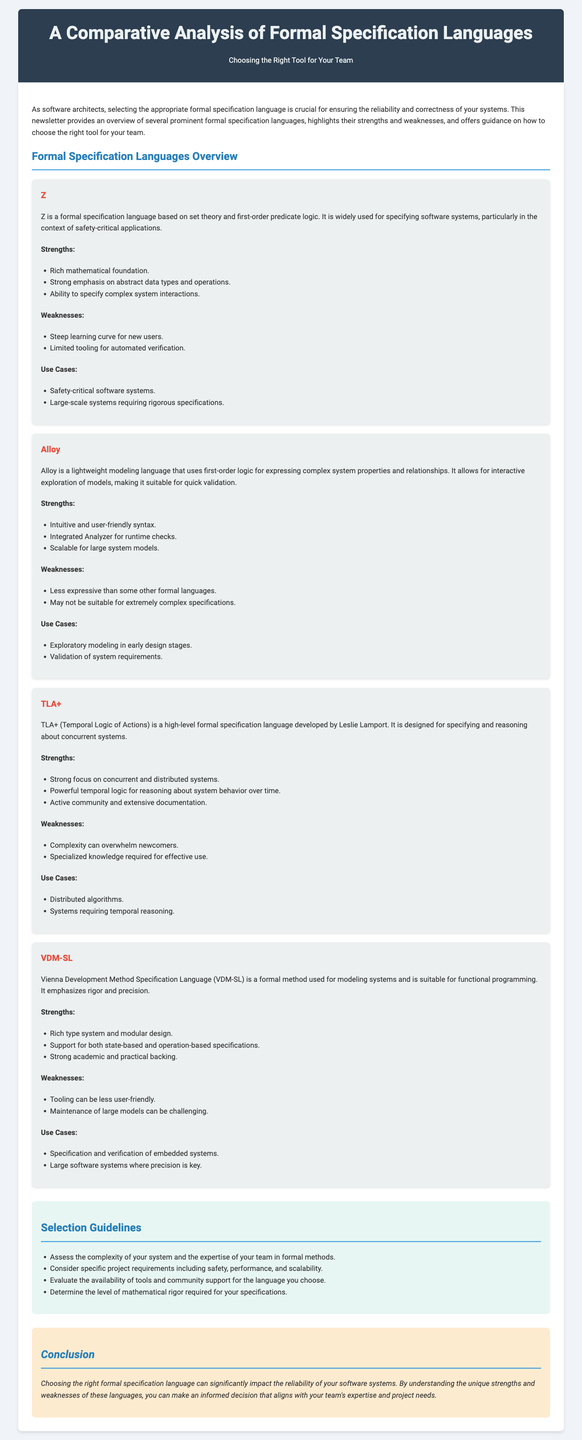What is the title of the newsletter? The title of the newsletter is prominently displayed in the header section of the document.
Answer: A Comparative Analysis of Formal Specification Languages Which language is described as having a steep learning curve? The text describes Z as having a steep learning curve for new users in the weaknesses section.
Answer: Z What is a strength of TLA+? A strength of TLA+ is mentioned in the strengths section, focusing on its capabilities.
Answer: Strong focus on concurrent and distributed systems How many formal specification languages are discussed in the newsletter? The document outlines four formal specification languages, as detailed in the overview section.
Answer: Four What is a use case for Alloy? The use cases for Alloy state that it is used for exploratory modeling in early design stages.
Answer: Exploratory modeling in early design stages What should you assess when selecting a formal specification language? The guidelines suggest assessing the complexity of your system and the expertise of your team.
Answer: Complexity of your system and expertise of your team Which formal method emphasizes rigor and precision? VDM-SL is specifically noted for its emphasis on rigor and precision in the document.
Answer: VDM-SL What is a weakness of Alloy? The weaknesses section lists that Alloy is less expressive than some other formal languages.
Answer: Less expressive than some other formal languages 